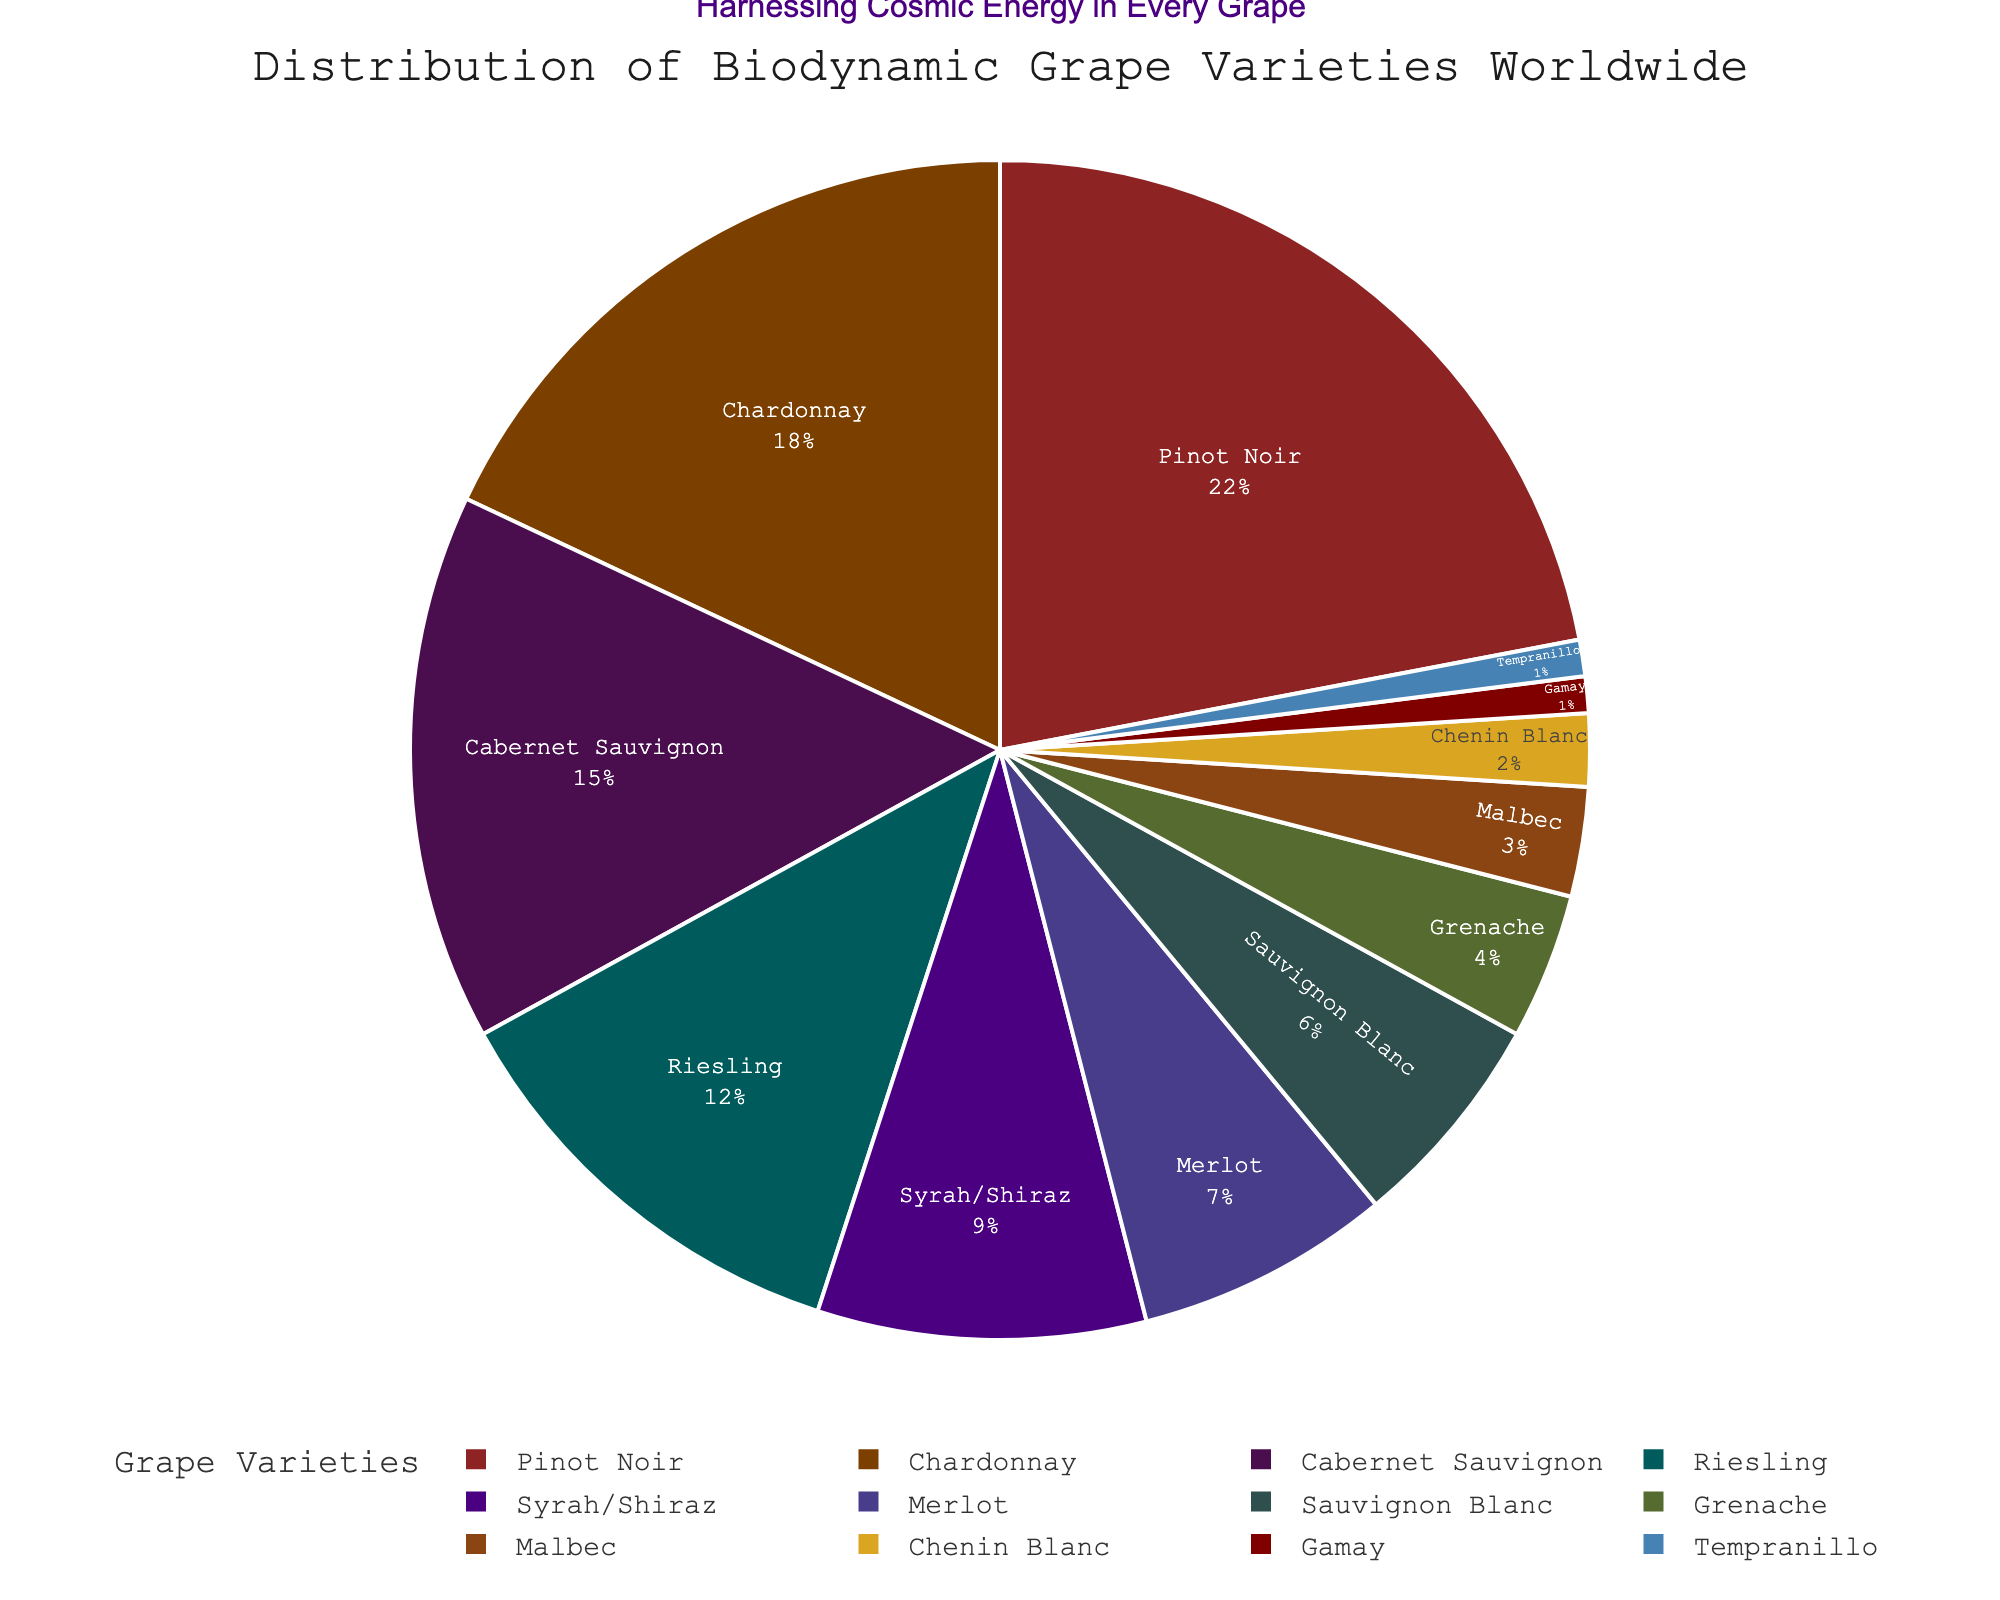Which grape variety has the highest percentage? By examining the pie chart, the segment with the largest area represents the highest percentage. Pinot Noir has the largest segment, indicating it has the highest percentage.
Answer: Pinot Noir What is the combined percentage of Chardonnay and Riesling? To find the combined percentage, sum the percentages of Chardonnay (18%) and Riesling (12%). 18 + 12 equals 30%.
Answer: 30% How much larger is the percentage of Pinot Noir compared to Malbec? To find the difference, subtract Malbec's percentage (3%) from Pinot Noir's percentage (22%). 22 - 3 equals 19.
Answer: 19% Which grape variety has a slightly larger share: Syrah/Shiraz or Merlot? By comparing the segments, Syrah/Shiraz has a slightly larger share than Merlot. Syrah/Shiraz is 9% and Merlot is 7%.
Answer: Syrah/Shiraz What percentage of the varieties on the chart is made up by Cabernet Sauvignon, Grenache, and Gamay? To find the total percentage, sum the percentages of Cabernet Sauvignon (15%), Grenache (4%), and Gamay (1%). 15 + 4 + 1 equals 20%.
Answer: 20% Which two grape varieties have the same percentage? By inspecting the pie chart, Tempranillo and Gamay both have the same percentage. They both have 1%.
Answer: Tempranillo and Gamay How many varieties have a percentage less than 5%? From the pie chart, count the varieties with a percentage less than 5%. Grenache, Malbec, Chenin Blanc, Gamay, and Tempranillo meet that criteria, totaling 5 varieties.
Answer: 5 What is the difference in percentage between the largest and smallest grape varieties? To find the difference, subtract the percentage of the smallest variety (Tempranillo or Gamay at 1%) from the largest variety (Pinot Noir at 22%). 22 - 1 equals 21.
Answer: 21% What is the total percentage of the three most common grape varieties? Sum the percentages of Pinot Noir (22%), Chardonnay (18%), and Cabernet Sauvignon (15%). 22 + 18 + 15 equals 55%.
Answer: 55% What is the percentage of white grape varieties if we consider Chardonnay, Riesling, Sauvignon Blanc, and Chenin Blanc as white? Sum the percentages of Chardonnay (18%), Riesling (12%), Sauvignon Blanc (6%), and Chenin Blanc (2%). 18 + 12 + 6 + 2 equals 38%.
Answer: 38% 